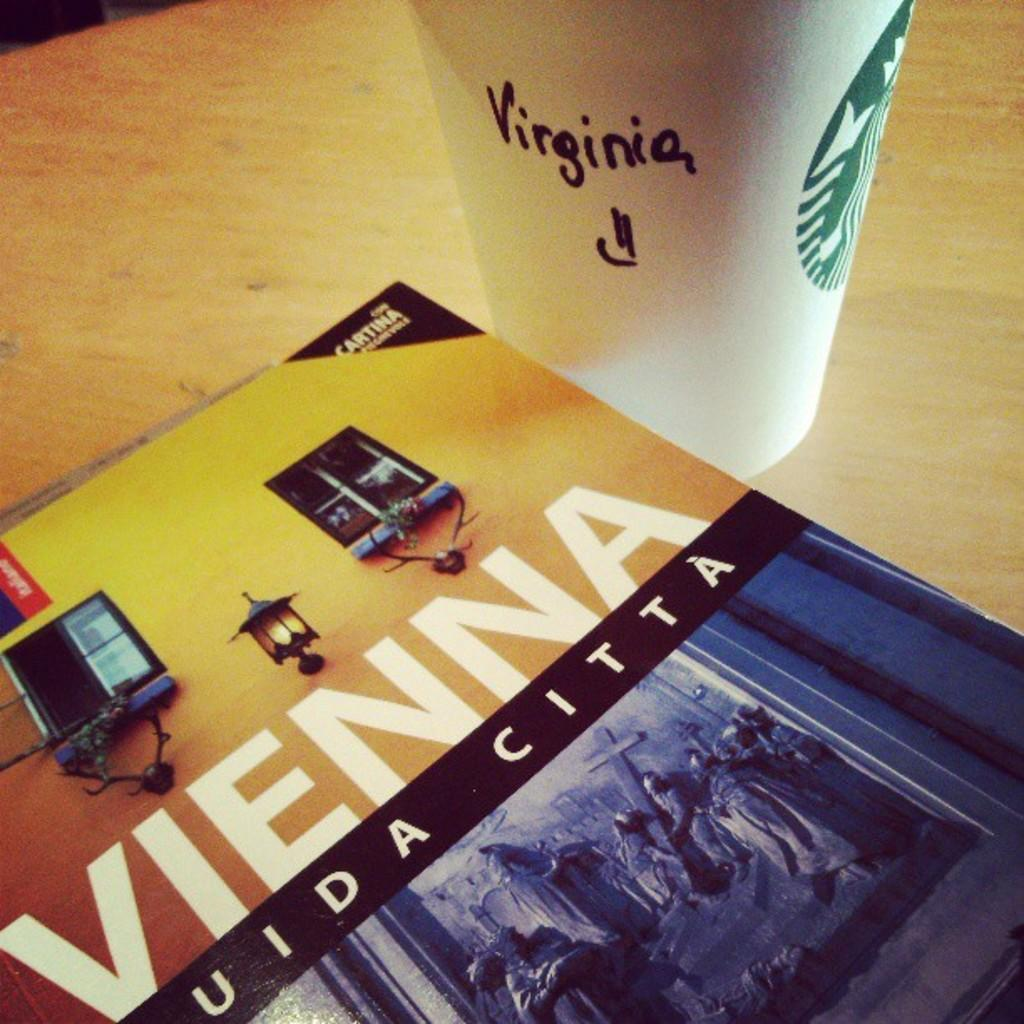<image>
Offer a succinct explanation of the picture presented. The book "Vienna" is sitting on a table with a Starbucks coffee cup with the name "Virginia" written on the cup in black marking pen. 